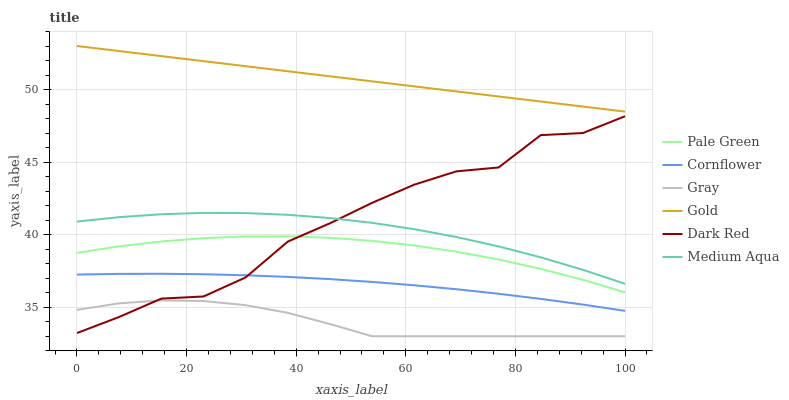Does Gray have the minimum area under the curve?
Answer yes or no. Yes. Does Gold have the maximum area under the curve?
Answer yes or no. Yes. Does Gold have the minimum area under the curve?
Answer yes or no. No. Does Gray have the maximum area under the curve?
Answer yes or no. No. Is Gold the smoothest?
Answer yes or no. Yes. Is Dark Red the roughest?
Answer yes or no. Yes. Is Gray the smoothest?
Answer yes or no. No. Is Gray the roughest?
Answer yes or no. No. Does Gray have the lowest value?
Answer yes or no. Yes. Does Gold have the lowest value?
Answer yes or no. No. Does Gold have the highest value?
Answer yes or no. Yes. Does Gray have the highest value?
Answer yes or no. No. Is Pale Green less than Gold?
Answer yes or no. Yes. Is Gold greater than Medium Aqua?
Answer yes or no. Yes. Does Gray intersect Dark Red?
Answer yes or no. Yes. Is Gray less than Dark Red?
Answer yes or no. No. Is Gray greater than Dark Red?
Answer yes or no. No. Does Pale Green intersect Gold?
Answer yes or no. No. 